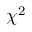<formula> <loc_0><loc_0><loc_500><loc_500>\chi ^ { 2 }</formula> 